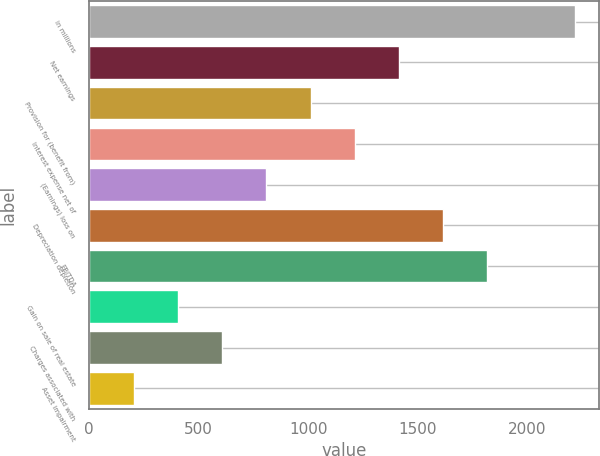<chart> <loc_0><loc_0><loc_500><loc_500><bar_chart><fcel>in millions<fcel>Net earnings<fcel>Provision for (benefit from)<fcel>Interest expense net of<fcel>(Earnings) loss on<fcel>Depreciation depletion<fcel>EBITDA<fcel>Gain on sale of real estate<fcel>Charges associated with<fcel>Asset impairment<nl><fcel>2216<fcel>1412<fcel>1010<fcel>1211<fcel>809<fcel>1613<fcel>1814<fcel>407<fcel>608<fcel>206<nl></chart> 